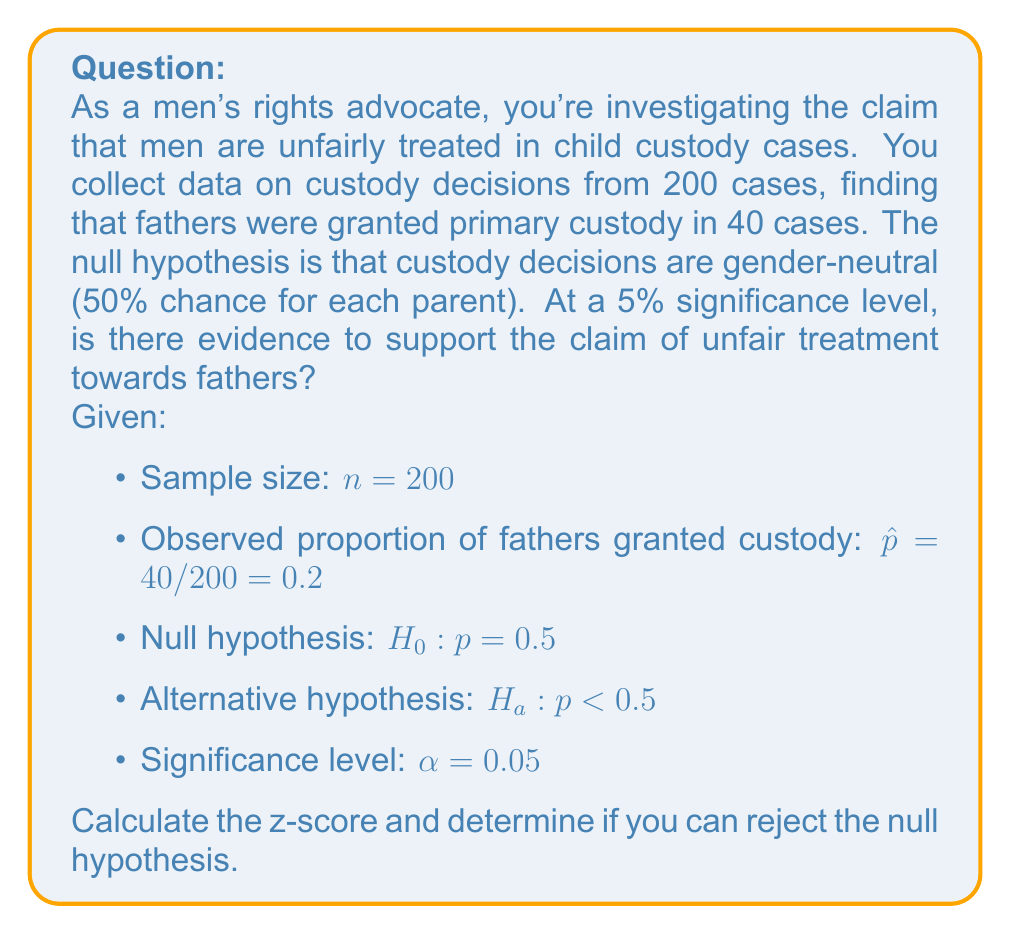Solve this math problem. To evaluate the statistical significance, we'll use a one-proportion z-test:

1) Calculate the standard error:
   $SE = \sqrt{\frac{p_0(1-p_0)}{n}} = \sqrt{\frac{0.5(1-0.5)}{200}} = 0.0354$

2) Calculate the z-score:
   $z = \frac{\hat{p} - p_0}{SE} = \frac{0.2 - 0.5}{0.0354} = -8.47$

3) Find the critical value:
   For a one-tailed test at $\alpha = 0.05$, $z_{\text{critical}} = -1.645$

4) Compare z-score to critical value:
   $-8.47 < -1.645$

5) Calculate p-value:
   $p\text{-value} = P(Z < -8.47) \approx 1.21 \times 10^{-17}$

Since the z-score (-8.47) is less than the critical value (-1.645) and the p-value ($1.21 \times 10^{-17}$) is less than $\alpha$ (0.05), we reject the null hypothesis.
Answer: Reject $H_0$; strong evidence of unfair treatment towards fathers in custody decisions. 